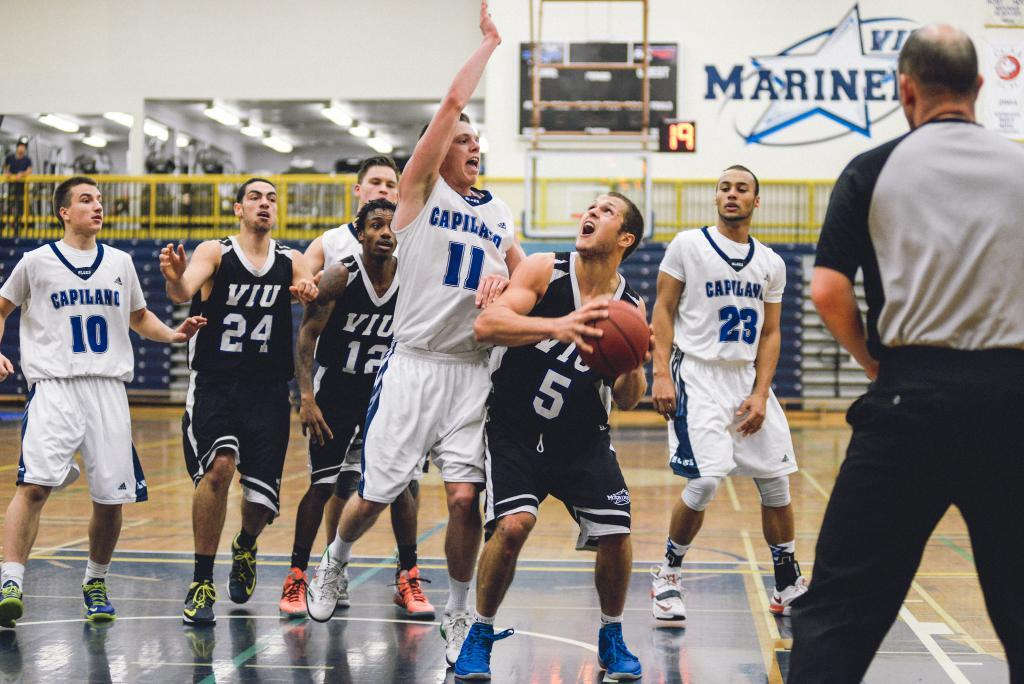How many people are in the image? There is a group of people in the image. What are the people doing in the image? The people are standing on the ground. Is there any object being held by one of the people? Yes, one person is holding a ball. What can be seen in the background of the image? There is a fence and a wall in the background of the image. What is the process of creating the belief system held by the people in the image? There is no information about the people's belief system in the image, so it cannot be determined from the image. 